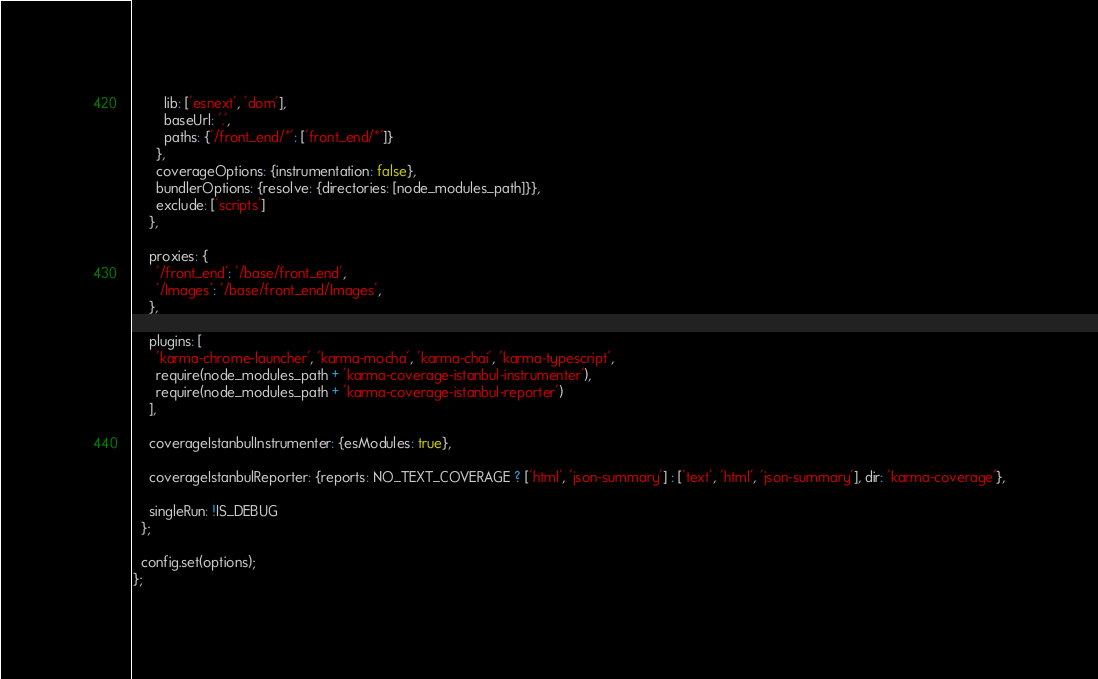Convert code to text. <code><loc_0><loc_0><loc_500><loc_500><_JavaScript_>        lib: ['esnext', 'dom'],
        baseUrl: '.',
        paths: {'/front_end/*': ['front_end/*']}
      },
      coverageOptions: {instrumentation: false},
      bundlerOptions: {resolve: {directories: [node_modules_path]}},
      exclude: ['scripts']
    },

    proxies: {
      '/front_end': '/base/front_end',
      '/Images': '/base/front_end/Images',
    },

    plugins: [
      'karma-chrome-launcher', 'karma-mocha', 'karma-chai', 'karma-typescript',
      require(node_modules_path + 'karma-coverage-istanbul-instrumenter'),
      require(node_modules_path + 'karma-coverage-istanbul-reporter')
    ],

    coverageIstanbulInstrumenter: {esModules: true},

    coverageIstanbulReporter: {reports: NO_TEXT_COVERAGE ? ['html', 'json-summary'] : ['text', 'html', 'json-summary'], dir: 'karma-coverage'},

    singleRun: !IS_DEBUG
  };

  config.set(options);
};
</code> 